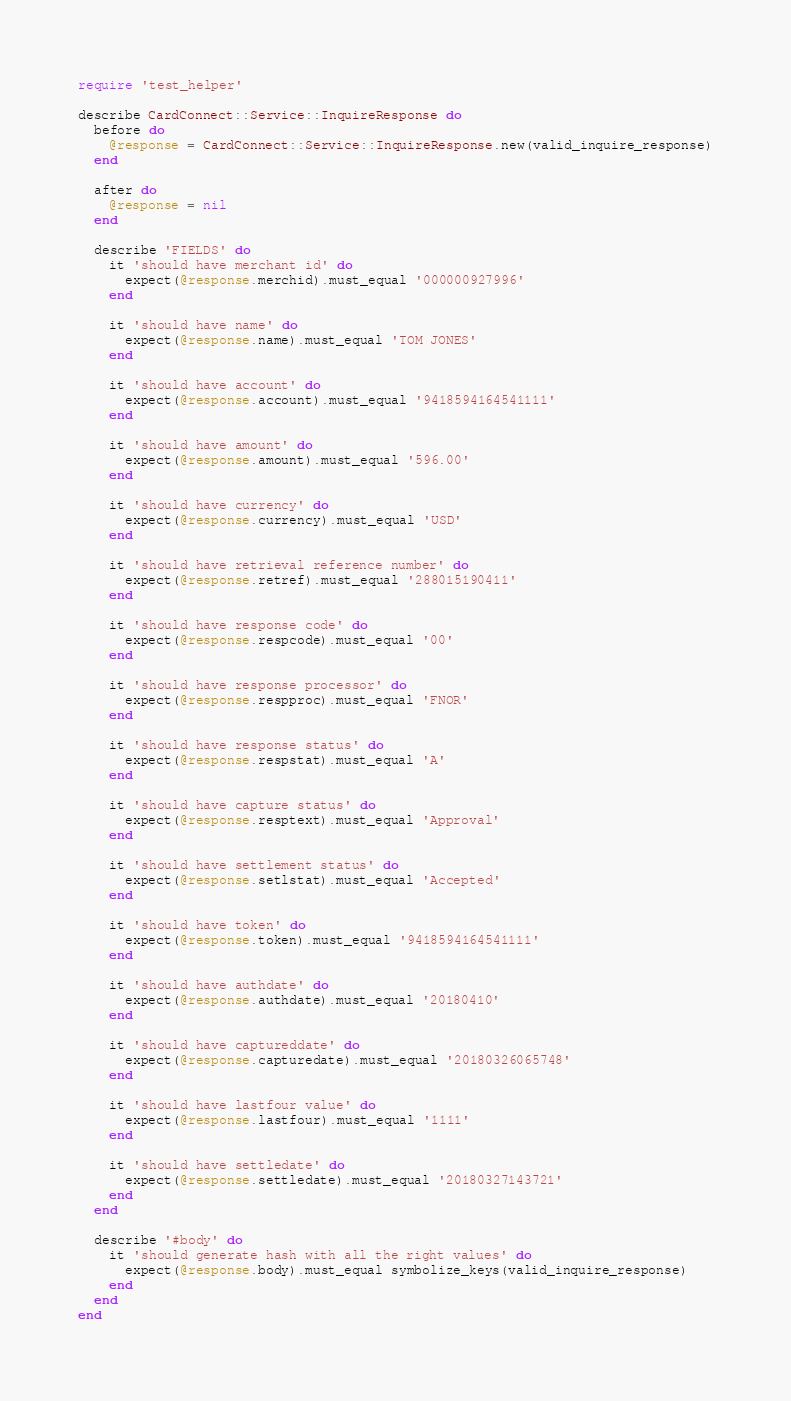Convert code to text. <code><loc_0><loc_0><loc_500><loc_500><_Ruby_>require 'test_helper'

describe CardConnect::Service::InquireResponse do
  before do
    @response = CardConnect::Service::InquireResponse.new(valid_inquire_response)
  end

  after do
    @response = nil
  end

  describe 'FIELDS' do
    it 'should have merchant id' do
      expect(@response.merchid).must_equal '000000927996'
    end

    it 'should have name' do
      expect(@response.name).must_equal 'TOM JONES'
    end

    it 'should have account' do
      expect(@response.account).must_equal '9418594164541111'
    end

    it 'should have amount' do
      expect(@response.amount).must_equal '596.00'
    end

    it 'should have currency' do
      expect(@response.currency).must_equal 'USD'
    end

    it 'should have retrieval reference number' do
      expect(@response.retref).must_equal '288015190411'
    end

    it 'should have response code' do
      expect(@response.respcode).must_equal '00'
    end

    it 'should have response processor' do
      expect(@response.respproc).must_equal 'FNOR'
    end

    it 'should have response status' do
      expect(@response.respstat).must_equal 'A'
    end

    it 'should have capture status' do
      expect(@response.resptext).must_equal 'Approval'
    end

    it 'should have settlement status' do
      expect(@response.setlstat).must_equal 'Accepted'
    end

    it 'should have token' do
      expect(@response.token).must_equal '9418594164541111'
    end

    it 'should have authdate' do
      expect(@response.authdate).must_equal '20180410'
    end

    it 'should have captureddate' do
      expect(@response.capturedate).must_equal '20180326065748'
    end

    it 'should have lastfour value' do
      expect(@response.lastfour).must_equal '1111'
    end

    it 'should have settledate' do
      expect(@response.settledate).must_equal '20180327143721'
    end
  end

  describe '#body' do
    it 'should generate hash with all the right values' do
      expect(@response.body).must_equal symbolize_keys(valid_inquire_response)
    end
  end
end
</code> 